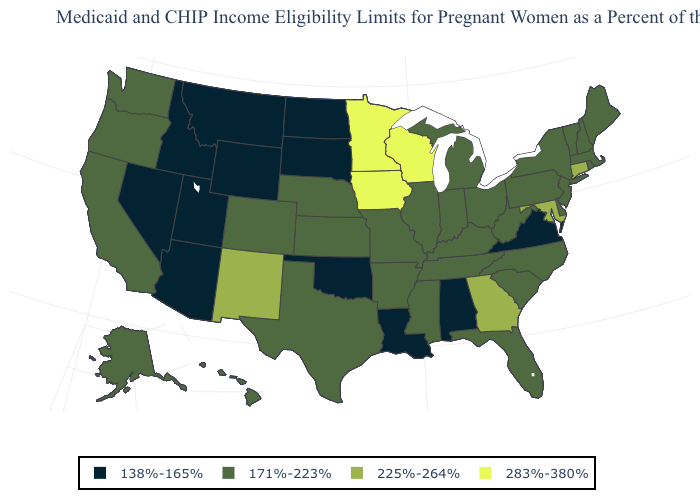What is the highest value in the USA?
Answer briefly. 283%-380%. What is the value of Virginia?
Write a very short answer. 138%-165%. Among the states that border Georgia , does Florida have the highest value?
Short answer required. Yes. Among the states that border Nevada , does Arizona have the highest value?
Quick response, please. No. Which states have the lowest value in the USA?
Give a very brief answer. Alabama, Arizona, Idaho, Louisiana, Montana, Nevada, North Dakota, Oklahoma, South Dakota, Utah, Virginia, Wyoming. Is the legend a continuous bar?
Short answer required. No. Name the states that have a value in the range 225%-264%?
Write a very short answer. Connecticut, Georgia, Maryland, New Mexico. Is the legend a continuous bar?
Short answer required. No. Name the states that have a value in the range 225%-264%?
Give a very brief answer. Connecticut, Georgia, Maryland, New Mexico. Name the states that have a value in the range 225%-264%?
Be succinct. Connecticut, Georgia, Maryland, New Mexico. Among the states that border Colorado , does Arizona have the lowest value?
Write a very short answer. Yes. Name the states that have a value in the range 171%-223%?
Be succinct. Alaska, Arkansas, California, Colorado, Delaware, Florida, Hawaii, Illinois, Indiana, Kansas, Kentucky, Maine, Massachusetts, Michigan, Mississippi, Missouri, Nebraska, New Hampshire, New Jersey, New York, North Carolina, Ohio, Oregon, Pennsylvania, Rhode Island, South Carolina, Tennessee, Texas, Vermont, Washington, West Virginia. Does Nevada have the same value as Iowa?
Quick response, please. No. What is the lowest value in the USA?
Quick response, please. 138%-165%. 